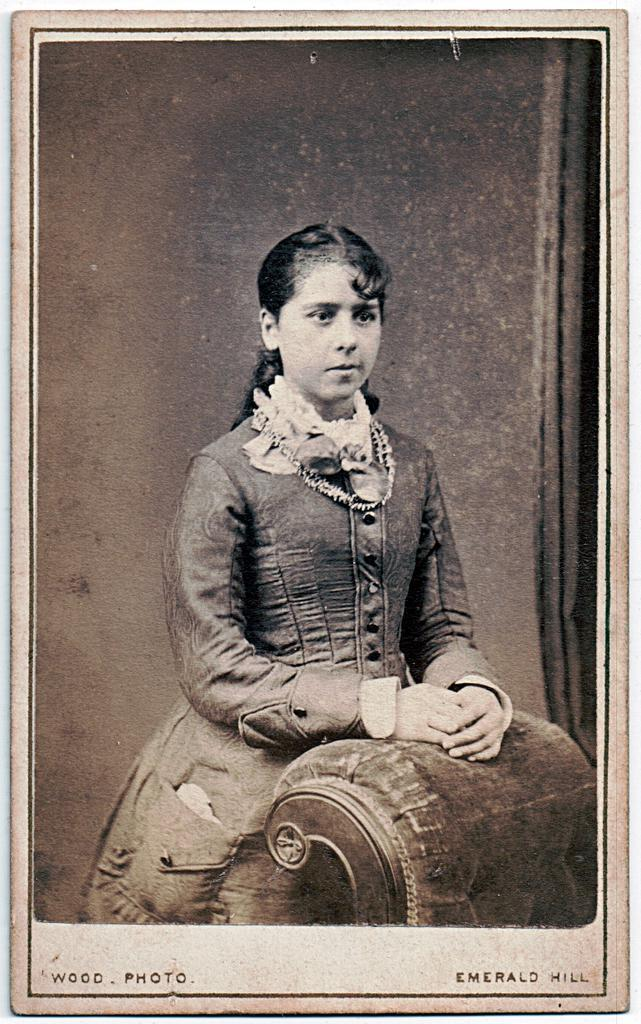What is the main subject of the image? There is a girl standing in the image. What is the girl wearing? The girl is wearing clothes and a neck chain. What accessory can be seen in the image? There is a handbag in the image. What color scheme is used in the image? The image is in black and white. What type of plantation can be seen in the background of the image? There is no plantation present in the image; it features a girl standing with a handbag. What is being served for dinner in the image? There is no dinner or food present in the image; it is focused on the girl and her accessories. 